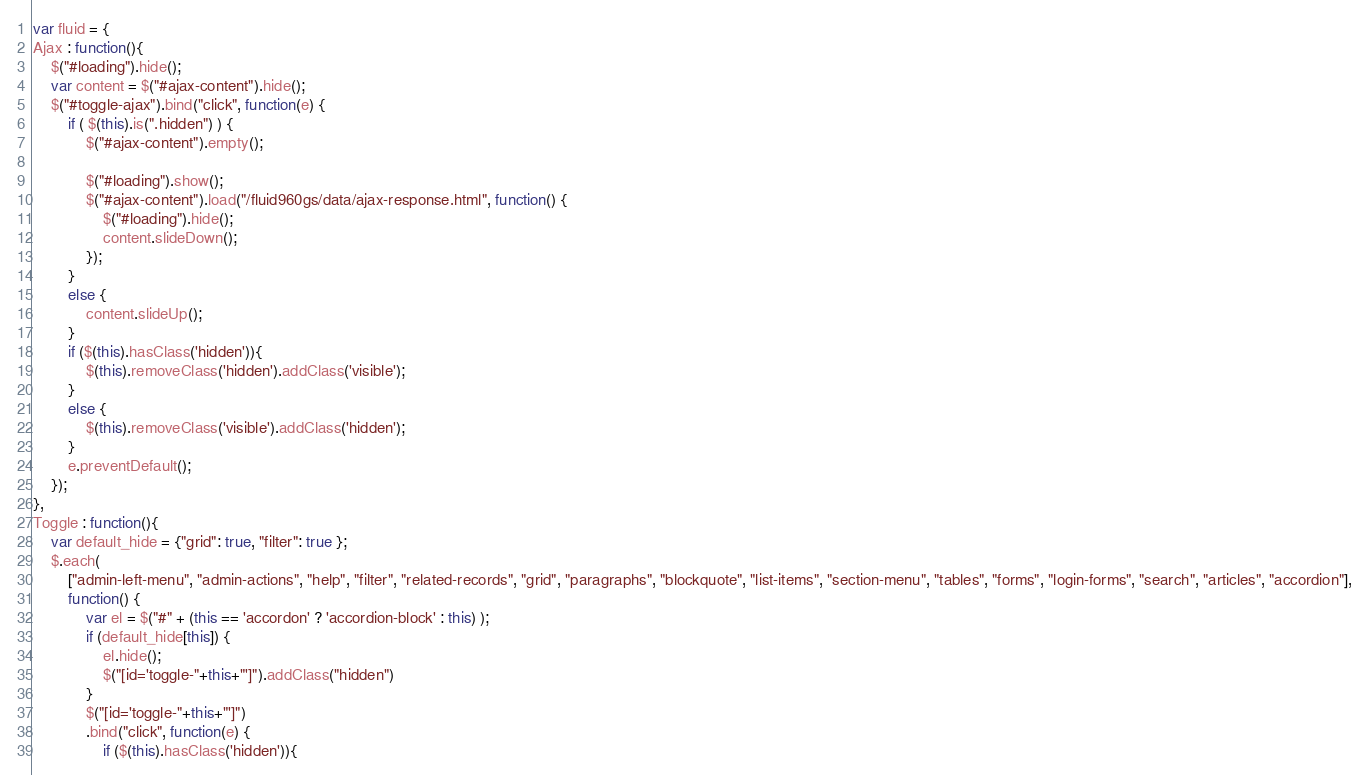Convert code to text. <code><loc_0><loc_0><loc_500><loc_500><_JavaScript_>var fluid = {
Ajax : function(){
	$("#loading").hide();
	var content = $("#ajax-content").hide();
	$("#toggle-ajax").bind("click", function(e) {
        if ( $(this).is(".hidden") ) {
            $("#ajax-content").empty();

            $("#loading").show();
            $("#ajax-content").load("/fluid960gs/data/ajax-response.html", function() {
            	$("#loading").hide();
            	content.slideDown();
            });
        }
        else {
            content.slideUp();
        }
        if ($(this).hasClass('hidden')){
            $(this).removeClass('hidden').addClass('visible');
        }
        else {
            $(this).removeClass('visible').addClass('hidden');
        }
        e.preventDefault();
    });
},
Toggle : function(){
	var default_hide = {"grid": true, "filter": true };
	$.each(
		["admin-left-menu", "admin-actions", "help", "filter", "related-records", "grid", "paragraphs", "blockquote", "list-items", "section-menu", "tables", "forms", "login-forms", "search", "articles", "accordion"],
		function() {
			var el = $("#" + (this == 'accordon' ? 'accordion-block' : this) );
			if (default_hide[this]) {
				el.hide();
				$("[id='toggle-"+this+"']").addClass("hidden")
			}
			$("[id='toggle-"+this+"']")
			.bind("click", function(e) {
				if ($(this).hasClass('hidden')){</code> 